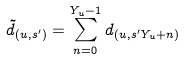<formula> <loc_0><loc_0><loc_500><loc_500>\tilde { d } _ { ( u , s ^ { \prime } ) } = \sum _ { n = 0 } ^ { Y _ { u } - 1 } d _ { ( u , s ^ { \prime } Y _ { u } + n ) }</formula> 